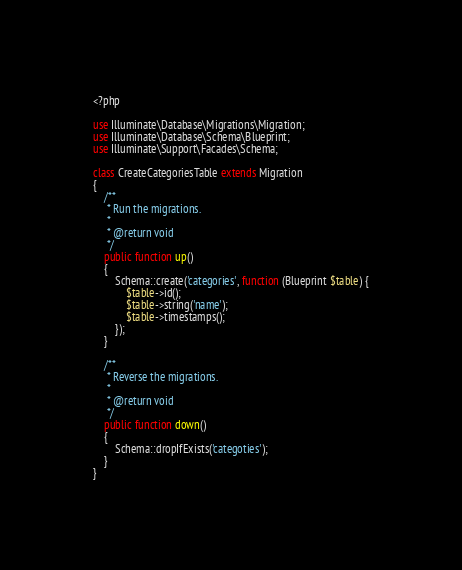Convert code to text. <code><loc_0><loc_0><loc_500><loc_500><_PHP_><?php

use Illuminate\Database\Migrations\Migration;
use Illuminate\Database\Schema\Blueprint;
use Illuminate\Support\Facades\Schema;

class CreateCategoriesTable extends Migration
{
    /**
     * Run the migrations.
     *
     * @return void
     */
    public function up()
    {
        Schema::create('categories', function (Blueprint $table) {
            $table->id();
            $table->string('name');
            $table->timestamps();
        });
    }

    /**
     * Reverse the migrations.
     *
     * @return void
     */
    public function down()
    {
        Schema::dropIfExists('categoties');
    }
}
</code> 